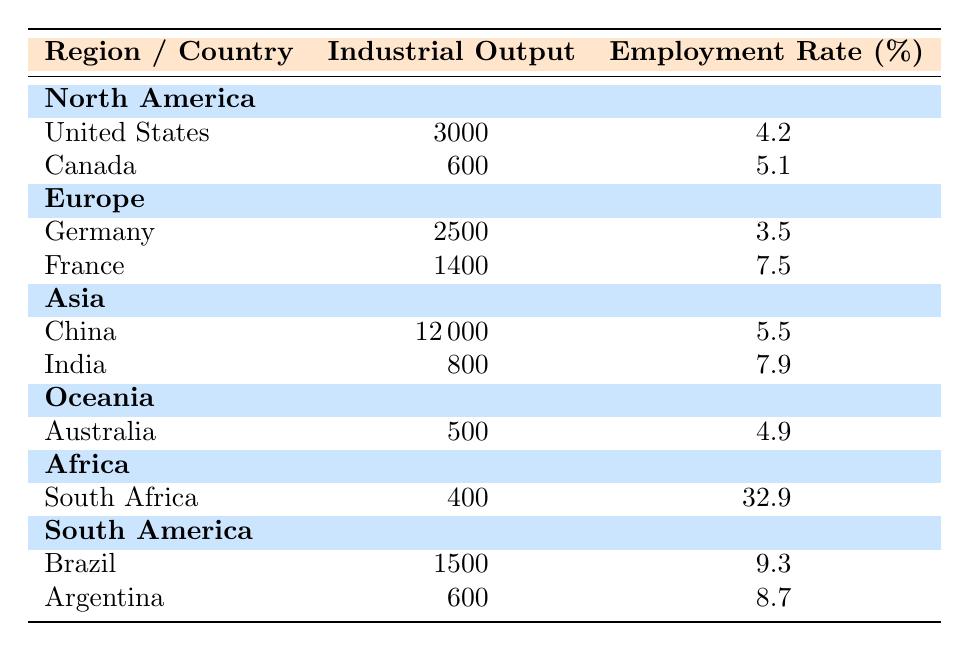What is the industrial output of China? The table lists China under the Asia region with an industrial output of 12000.
Answer: 12000 Which country has the highest employment rate? South Africa is listed with the highest employment rate of 32.9% in the Africa region.
Answer: 32.9% What is the total industrial output of North America? The industrial output of North America is the sum of the outputs from the United States (3000) and Canada (600), resulting in 3000 + 600 = 3600.
Answer: 3600 How many countries in Europe have an employment rate above 5%? Germany has an employment rate of 3.5% and France has 7.5%. Only France is above 5%, giving a total of 1 country.
Answer: 1 Is the employment rate in India greater than that in Germany? India has an employment rate of 7.9% while Germany has 3.5%, thus India's rate is greater.
Answer: Yes What is the average employment rate of South American countries? The employment rates for Brazil (9.3%) and Argentina (8.7%) together yield an average of (9.3 + 8.7) / 2 = 9.0.
Answer: 9.0 Which region has the highest total industrial output? Summing the industrial outputs for each region: North America (3600), Europe (3900), Asia (12800), Oceania (500), Africa (400), and South America (2100) reveals that Asia has the highest output at 12800.
Answer: Asia Which country has the lowest industrial output? According to the table, South Africa has the lowest industrial output of 400 in the Africa region.
Answer: 400 What is the difference in employment rates between the highest and lowest in this dataset? The highest employment rate is South Africa's 32.9% and the lowest is Germany's 3.5%. The difference is 32.9 - 3.5 = 29.4.
Answer: 29.4 How does the average industrial output of Oceania compare to that of Asia? Oceania's industrial output is 500, while Asia's is 12000. Therefore, Oceania has a considerably lower output.
Answer: Lower 